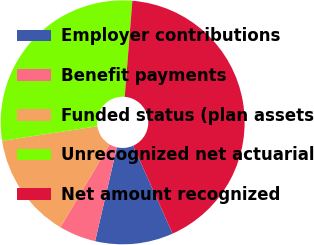Convert chart to OTSL. <chart><loc_0><loc_0><loc_500><loc_500><pie_chart><fcel>Employer contributions<fcel>Benefit payments<fcel>Funded status (plan assets<fcel>Unrecognized net actuarial<fcel>Net amount recognized<nl><fcel>10.34%<fcel>4.89%<fcel>14.06%<fcel>28.69%<fcel>42.02%<nl></chart> 